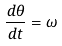Convert formula to latex. <formula><loc_0><loc_0><loc_500><loc_500>\frac { d \theta } { d t } = \omega</formula> 